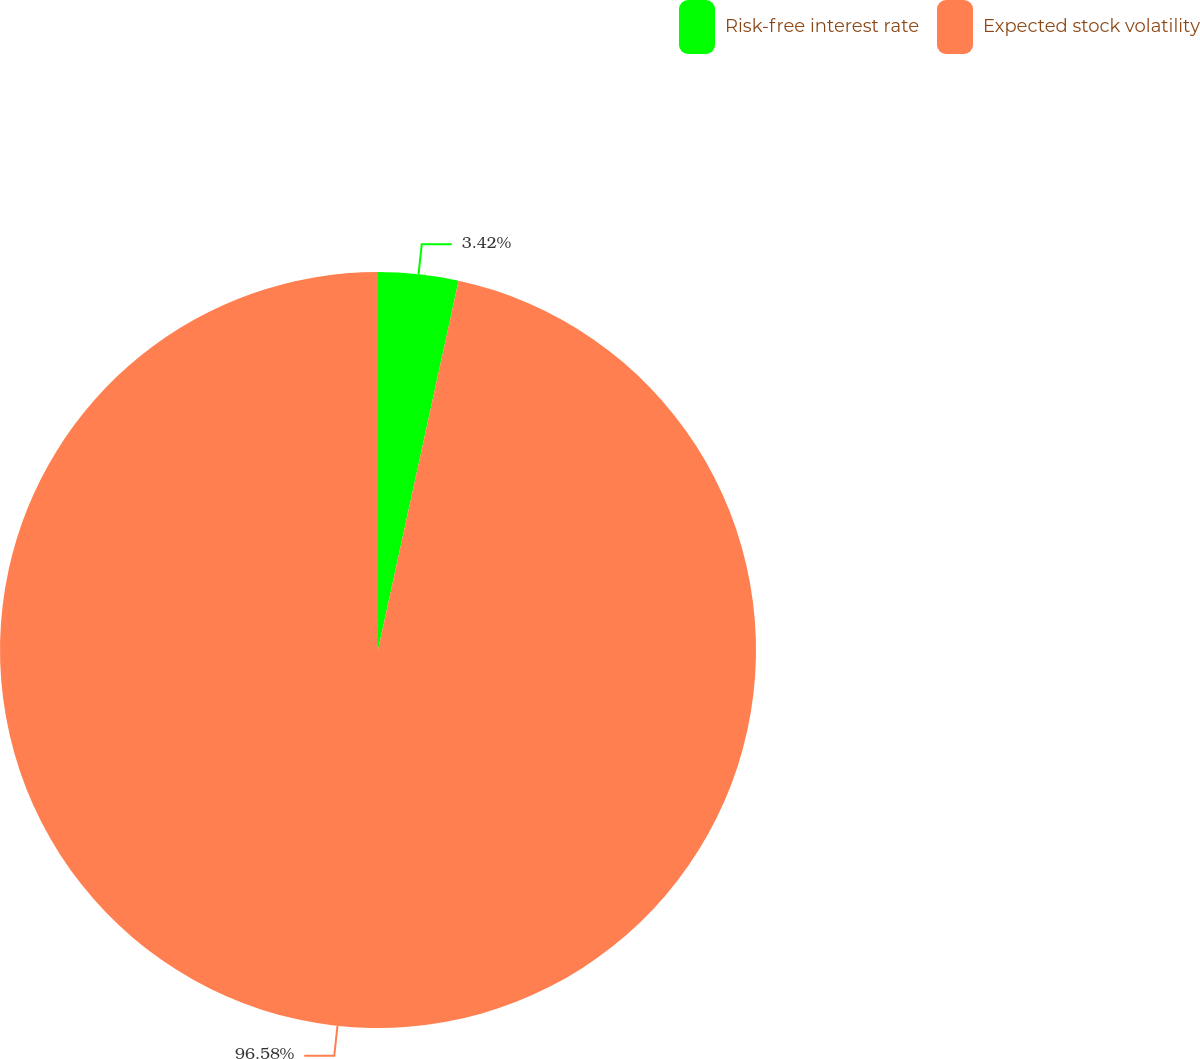Convert chart to OTSL. <chart><loc_0><loc_0><loc_500><loc_500><pie_chart><fcel>Risk-free interest rate<fcel>Expected stock volatility<nl><fcel>3.42%<fcel>96.58%<nl></chart> 